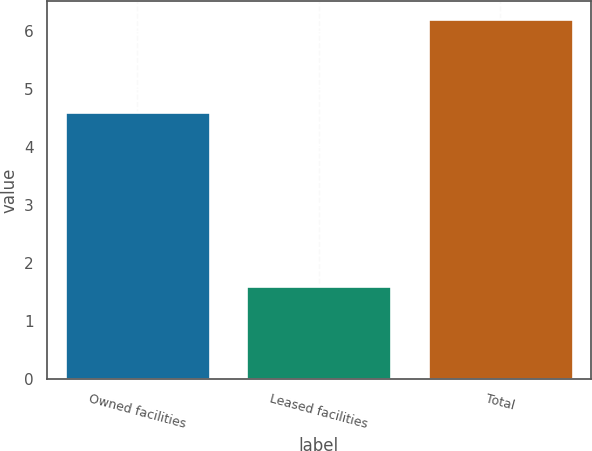Convert chart. <chart><loc_0><loc_0><loc_500><loc_500><bar_chart><fcel>Owned facilities<fcel>Leased facilities<fcel>Total<nl><fcel>4.6<fcel>1.6<fcel>6.2<nl></chart> 